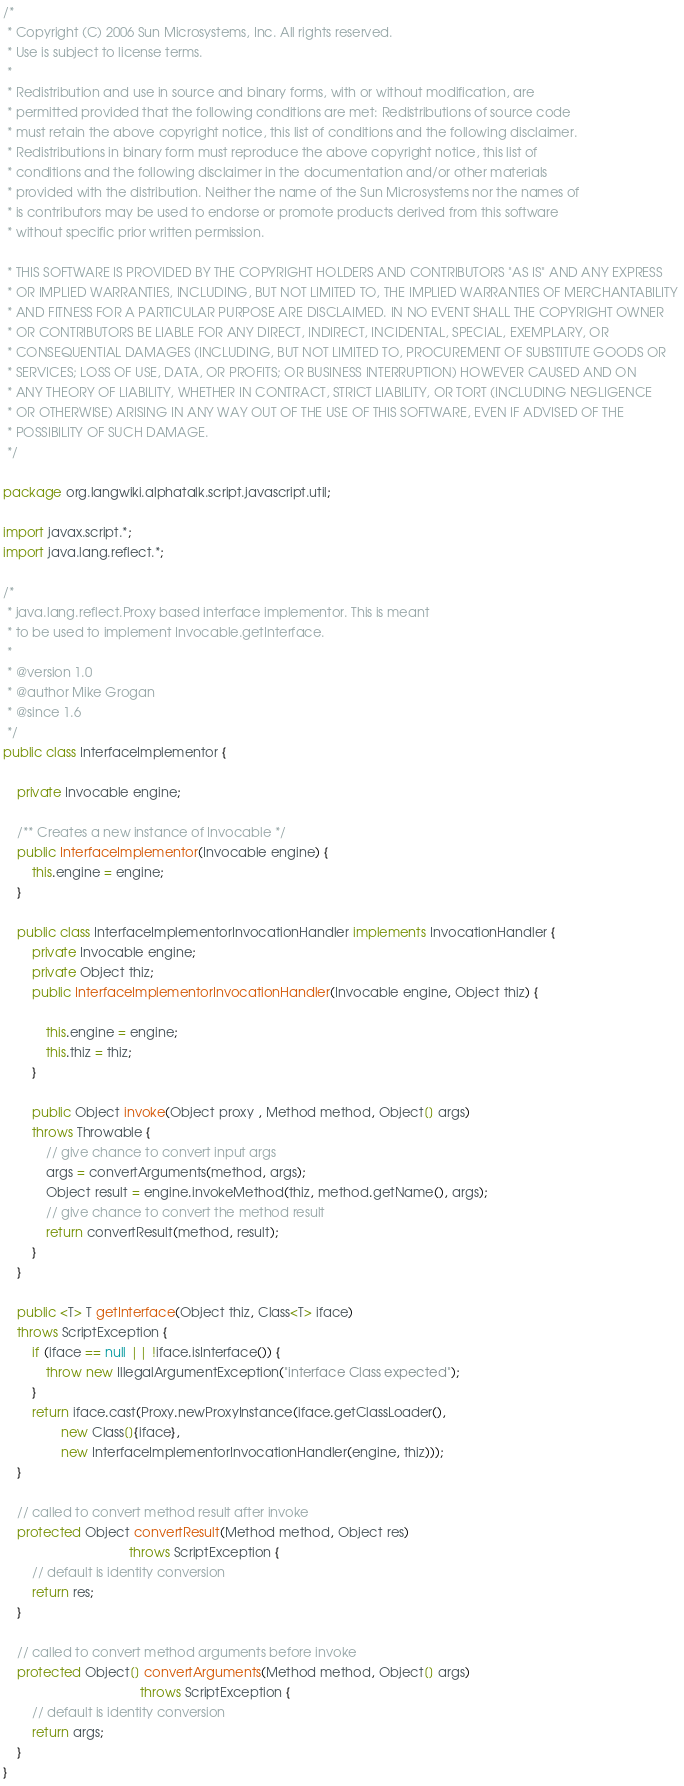Convert code to text. <code><loc_0><loc_0><loc_500><loc_500><_Java_>/*
 * Copyright (C) 2006 Sun Microsystems, Inc. All rights reserved. 
 * Use is subject to license terms.
 *
 * Redistribution and use in source and binary forms, with or without modification, are 
 * permitted provided that the following conditions are met: Redistributions of source code 
 * must retain the above copyright notice, this list of conditions and the following disclaimer.
 * Redistributions in binary form must reproduce the above copyright notice, this list of 
 * conditions and the following disclaimer in the documentation and/or other materials 
 * provided with the distribution. Neither the name of the Sun Microsystems nor the names of 
 * is contributors may be used to endorse or promote products derived from this software 
 * without specific prior written permission. 

 * THIS SOFTWARE IS PROVIDED BY THE COPYRIGHT HOLDERS AND CONTRIBUTORS "AS IS" AND ANY EXPRESS
 * OR IMPLIED WARRANTIES, INCLUDING, BUT NOT LIMITED TO, THE IMPLIED WARRANTIES OF MERCHANTABILITY 
 * AND FITNESS FOR A PARTICULAR PURPOSE ARE DISCLAIMED. IN NO EVENT SHALL THE COPYRIGHT OWNER 
 * OR CONTRIBUTORS BE LIABLE FOR ANY DIRECT, INDIRECT, INCIDENTAL, SPECIAL, EXEMPLARY, OR 
 * CONSEQUENTIAL DAMAGES (INCLUDING, BUT NOT LIMITED TO, PROCUREMENT OF SUBSTITUTE GOODS OR 
 * SERVICES; LOSS OF USE, DATA, OR PROFITS; OR BUSINESS INTERRUPTION) HOWEVER CAUSED AND ON 
 * ANY THEORY OF LIABILITY, WHETHER IN CONTRACT, STRICT LIABILITY, OR TORT (INCLUDING NEGLIGENCE
 * OR OTHERWISE) ARISING IN ANY WAY OUT OF THE USE OF THIS SOFTWARE, EVEN IF ADVISED OF THE
 * POSSIBILITY OF SUCH DAMAGE.
 */

package org.langwiki.alphatalk.script.javascript.util;

import javax.script.*;
import java.lang.reflect.*;

/*
 * java.lang.reflect.Proxy based interface implementor. This is meant
 * to be used to implement Invocable.getInterface.
 *
 * @version 1.0
 * @author Mike Grogan
 * @since 1.6
 */
public class InterfaceImplementor {
    
    private Invocable engine;
    
    /** Creates a new instance of Invocable */
    public InterfaceImplementor(Invocable engine) {
        this.engine = engine;
    }
    
    public class InterfaceImplementorInvocationHandler implements InvocationHandler {
        private Invocable engine;
        private Object thiz;
        public InterfaceImplementorInvocationHandler(Invocable engine, Object thiz) {
            
            this.engine = engine;
            this.thiz = thiz;
        }
        
        public Object invoke(Object proxy , Method method, Object[] args)
        throws Throwable {
            // give chance to convert input args
            args = convertArguments(method, args);
            Object result = engine.invokeMethod(thiz, method.getName(), args);
            // give chance to convert the method result
            return convertResult(method, result);
        }
    }
    
    public <T> T getInterface(Object thiz, Class<T> iface)
    throws ScriptException {
        if (iface == null || !iface.isInterface()) {
            throw new IllegalArgumentException("interface Class expected");
        }
        return iface.cast(Proxy.newProxyInstance(iface.getClassLoader(),
                new Class[]{iface},
                new InterfaceImplementorInvocationHandler(engine, thiz)));
    }

    // called to convert method result after invoke
    protected Object convertResult(Method method, Object res) 
                                   throws ScriptException {
        // default is identity conversion
        return res;
    }

    // called to convert method arguments before invoke
    protected Object[] convertArguments(Method method, Object[] args)
                                      throws ScriptException {
        // default is identity conversion
        return args;
    }
}
</code> 